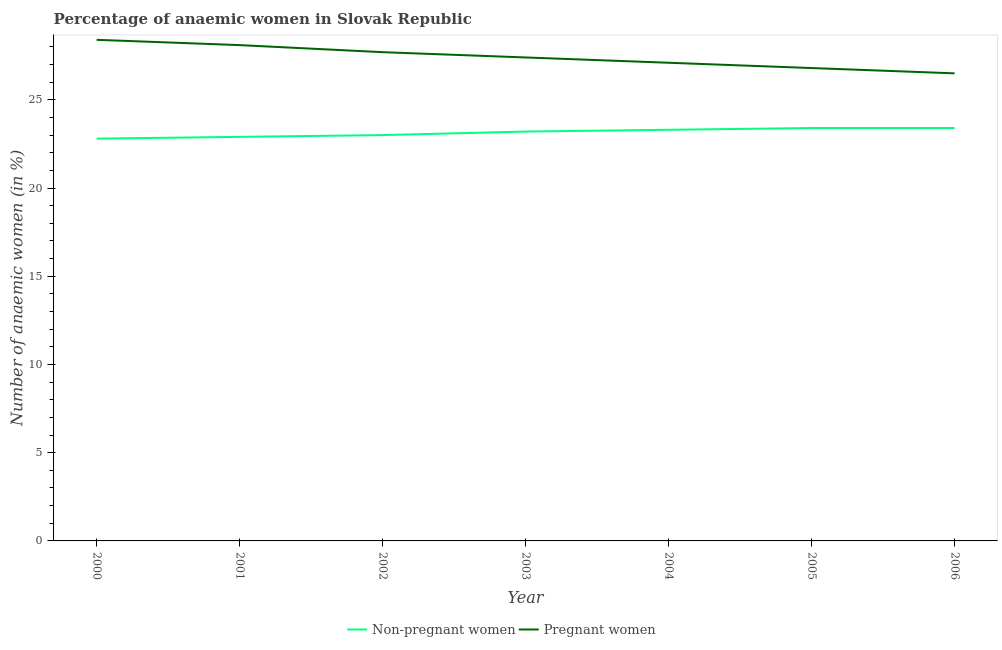What is the percentage of non-pregnant anaemic women in 2004?
Your response must be concise. 23.3. Across all years, what is the maximum percentage of pregnant anaemic women?
Give a very brief answer. 28.4. Across all years, what is the minimum percentage of pregnant anaemic women?
Your answer should be very brief. 26.5. What is the total percentage of non-pregnant anaemic women in the graph?
Provide a short and direct response. 162. What is the difference between the percentage of pregnant anaemic women in 2002 and the percentage of non-pregnant anaemic women in 2001?
Provide a succinct answer. 4.8. What is the average percentage of non-pregnant anaemic women per year?
Make the answer very short. 23.14. In the year 2000, what is the difference between the percentage of pregnant anaemic women and percentage of non-pregnant anaemic women?
Ensure brevity in your answer.  5.6. What is the ratio of the percentage of non-pregnant anaemic women in 2001 to that in 2005?
Make the answer very short. 0.98. Is the percentage of non-pregnant anaemic women in 2003 less than that in 2006?
Offer a very short reply. Yes. Is the difference between the percentage of non-pregnant anaemic women in 2000 and 2005 greater than the difference between the percentage of pregnant anaemic women in 2000 and 2005?
Make the answer very short. No. What is the difference between the highest and the lowest percentage of non-pregnant anaemic women?
Provide a succinct answer. 0.6. In how many years, is the percentage of pregnant anaemic women greater than the average percentage of pregnant anaemic women taken over all years?
Your response must be concise. 3. Does the percentage of non-pregnant anaemic women monotonically increase over the years?
Offer a very short reply. No. Is the percentage of non-pregnant anaemic women strictly less than the percentage of pregnant anaemic women over the years?
Offer a terse response. Yes. How many years are there in the graph?
Provide a short and direct response. 7. What is the difference between two consecutive major ticks on the Y-axis?
Ensure brevity in your answer.  5. Does the graph contain grids?
Give a very brief answer. No. Where does the legend appear in the graph?
Your response must be concise. Bottom center. How many legend labels are there?
Your answer should be compact. 2. How are the legend labels stacked?
Give a very brief answer. Horizontal. What is the title of the graph?
Make the answer very short. Percentage of anaemic women in Slovak Republic. Does "Males" appear as one of the legend labels in the graph?
Provide a succinct answer. No. What is the label or title of the X-axis?
Your answer should be compact. Year. What is the label or title of the Y-axis?
Keep it short and to the point. Number of anaemic women (in %). What is the Number of anaemic women (in %) in Non-pregnant women in 2000?
Make the answer very short. 22.8. What is the Number of anaemic women (in %) of Pregnant women in 2000?
Your response must be concise. 28.4. What is the Number of anaemic women (in %) of Non-pregnant women in 2001?
Keep it short and to the point. 22.9. What is the Number of anaemic women (in %) in Pregnant women in 2001?
Make the answer very short. 28.1. What is the Number of anaemic women (in %) of Pregnant women in 2002?
Your answer should be very brief. 27.7. What is the Number of anaemic women (in %) in Non-pregnant women in 2003?
Provide a short and direct response. 23.2. What is the Number of anaemic women (in %) of Pregnant women in 2003?
Your answer should be compact. 27.4. What is the Number of anaemic women (in %) in Non-pregnant women in 2004?
Your answer should be very brief. 23.3. What is the Number of anaemic women (in %) in Pregnant women in 2004?
Offer a very short reply. 27.1. What is the Number of anaemic women (in %) in Non-pregnant women in 2005?
Keep it short and to the point. 23.4. What is the Number of anaemic women (in %) in Pregnant women in 2005?
Provide a short and direct response. 26.8. What is the Number of anaemic women (in %) of Non-pregnant women in 2006?
Offer a terse response. 23.4. What is the Number of anaemic women (in %) in Pregnant women in 2006?
Offer a very short reply. 26.5. Across all years, what is the maximum Number of anaemic women (in %) of Non-pregnant women?
Keep it short and to the point. 23.4. Across all years, what is the maximum Number of anaemic women (in %) in Pregnant women?
Give a very brief answer. 28.4. Across all years, what is the minimum Number of anaemic women (in %) in Non-pregnant women?
Your response must be concise. 22.8. Across all years, what is the minimum Number of anaemic women (in %) of Pregnant women?
Offer a very short reply. 26.5. What is the total Number of anaemic women (in %) in Non-pregnant women in the graph?
Offer a very short reply. 162. What is the total Number of anaemic women (in %) in Pregnant women in the graph?
Provide a succinct answer. 192. What is the difference between the Number of anaemic women (in %) in Pregnant women in 2000 and that in 2001?
Keep it short and to the point. 0.3. What is the difference between the Number of anaemic women (in %) of Non-pregnant women in 2000 and that in 2002?
Keep it short and to the point. -0.2. What is the difference between the Number of anaemic women (in %) of Pregnant women in 2000 and that in 2002?
Ensure brevity in your answer.  0.7. What is the difference between the Number of anaemic women (in %) of Non-pregnant women in 2000 and that in 2003?
Keep it short and to the point. -0.4. What is the difference between the Number of anaemic women (in %) of Non-pregnant women in 2000 and that in 2004?
Keep it short and to the point. -0.5. What is the difference between the Number of anaemic women (in %) in Non-pregnant women in 2000 and that in 2005?
Ensure brevity in your answer.  -0.6. What is the difference between the Number of anaemic women (in %) in Non-pregnant women in 2000 and that in 2006?
Ensure brevity in your answer.  -0.6. What is the difference between the Number of anaemic women (in %) of Pregnant women in 2000 and that in 2006?
Your answer should be compact. 1.9. What is the difference between the Number of anaemic women (in %) of Non-pregnant women in 2001 and that in 2005?
Your response must be concise. -0.5. What is the difference between the Number of anaemic women (in %) of Pregnant women in 2001 and that in 2005?
Your response must be concise. 1.3. What is the difference between the Number of anaemic women (in %) of Non-pregnant women in 2001 and that in 2006?
Provide a short and direct response. -0.5. What is the difference between the Number of anaemic women (in %) in Non-pregnant women in 2002 and that in 2003?
Keep it short and to the point. -0.2. What is the difference between the Number of anaemic women (in %) of Non-pregnant women in 2002 and that in 2006?
Provide a short and direct response. -0.4. What is the difference between the Number of anaemic women (in %) in Pregnant women in 2002 and that in 2006?
Keep it short and to the point. 1.2. What is the difference between the Number of anaemic women (in %) in Pregnant women in 2003 and that in 2004?
Make the answer very short. 0.3. What is the difference between the Number of anaemic women (in %) of Non-pregnant women in 2003 and that in 2005?
Keep it short and to the point. -0.2. What is the difference between the Number of anaemic women (in %) in Non-pregnant women in 2003 and that in 2006?
Your answer should be compact. -0.2. What is the difference between the Number of anaemic women (in %) in Pregnant women in 2005 and that in 2006?
Your answer should be compact. 0.3. What is the difference between the Number of anaemic women (in %) in Non-pregnant women in 2000 and the Number of anaemic women (in %) in Pregnant women in 2001?
Provide a succinct answer. -5.3. What is the difference between the Number of anaemic women (in %) of Non-pregnant women in 2000 and the Number of anaemic women (in %) of Pregnant women in 2002?
Offer a terse response. -4.9. What is the difference between the Number of anaemic women (in %) of Non-pregnant women in 2000 and the Number of anaemic women (in %) of Pregnant women in 2004?
Your response must be concise. -4.3. What is the difference between the Number of anaemic women (in %) in Non-pregnant women in 2000 and the Number of anaemic women (in %) in Pregnant women in 2006?
Give a very brief answer. -3.7. What is the difference between the Number of anaemic women (in %) of Non-pregnant women in 2001 and the Number of anaemic women (in %) of Pregnant women in 2002?
Your answer should be very brief. -4.8. What is the difference between the Number of anaemic women (in %) of Non-pregnant women in 2001 and the Number of anaemic women (in %) of Pregnant women in 2003?
Provide a short and direct response. -4.5. What is the difference between the Number of anaemic women (in %) in Non-pregnant women in 2002 and the Number of anaemic women (in %) in Pregnant women in 2004?
Ensure brevity in your answer.  -4.1. What is the difference between the Number of anaemic women (in %) in Non-pregnant women in 2002 and the Number of anaemic women (in %) in Pregnant women in 2006?
Your response must be concise. -3.5. What is the difference between the Number of anaemic women (in %) in Non-pregnant women in 2003 and the Number of anaemic women (in %) in Pregnant women in 2004?
Your answer should be very brief. -3.9. What is the difference between the Number of anaemic women (in %) of Non-pregnant women in 2004 and the Number of anaemic women (in %) of Pregnant women in 2005?
Ensure brevity in your answer.  -3.5. What is the difference between the Number of anaemic women (in %) in Non-pregnant women in 2004 and the Number of anaemic women (in %) in Pregnant women in 2006?
Your answer should be compact. -3.2. What is the difference between the Number of anaemic women (in %) of Non-pregnant women in 2005 and the Number of anaemic women (in %) of Pregnant women in 2006?
Keep it short and to the point. -3.1. What is the average Number of anaemic women (in %) of Non-pregnant women per year?
Your response must be concise. 23.14. What is the average Number of anaemic women (in %) in Pregnant women per year?
Provide a short and direct response. 27.43. In the year 2001, what is the difference between the Number of anaemic women (in %) of Non-pregnant women and Number of anaemic women (in %) of Pregnant women?
Offer a very short reply. -5.2. In the year 2003, what is the difference between the Number of anaemic women (in %) in Non-pregnant women and Number of anaemic women (in %) in Pregnant women?
Give a very brief answer. -4.2. In the year 2006, what is the difference between the Number of anaemic women (in %) of Non-pregnant women and Number of anaemic women (in %) of Pregnant women?
Offer a very short reply. -3.1. What is the ratio of the Number of anaemic women (in %) in Pregnant women in 2000 to that in 2001?
Provide a succinct answer. 1.01. What is the ratio of the Number of anaemic women (in %) in Non-pregnant women in 2000 to that in 2002?
Your response must be concise. 0.99. What is the ratio of the Number of anaemic women (in %) of Pregnant women in 2000 to that in 2002?
Make the answer very short. 1.03. What is the ratio of the Number of anaemic women (in %) in Non-pregnant women in 2000 to that in 2003?
Your answer should be compact. 0.98. What is the ratio of the Number of anaemic women (in %) of Pregnant women in 2000 to that in 2003?
Give a very brief answer. 1.04. What is the ratio of the Number of anaemic women (in %) of Non-pregnant women in 2000 to that in 2004?
Provide a succinct answer. 0.98. What is the ratio of the Number of anaemic women (in %) of Pregnant women in 2000 to that in 2004?
Provide a succinct answer. 1.05. What is the ratio of the Number of anaemic women (in %) in Non-pregnant women in 2000 to that in 2005?
Keep it short and to the point. 0.97. What is the ratio of the Number of anaemic women (in %) of Pregnant women in 2000 to that in 2005?
Offer a terse response. 1.06. What is the ratio of the Number of anaemic women (in %) of Non-pregnant women in 2000 to that in 2006?
Your answer should be very brief. 0.97. What is the ratio of the Number of anaemic women (in %) of Pregnant women in 2000 to that in 2006?
Give a very brief answer. 1.07. What is the ratio of the Number of anaemic women (in %) in Non-pregnant women in 2001 to that in 2002?
Your answer should be very brief. 1. What is the ratio of the Number of anaemic women (in %) of Pregnant women in 2001 to that in 2002?
Ensure brevity in your answer.  1.01. What is the ratio of the Number of anaemic women (in %) in Non-pregnant women in 2001 to that in 2003?
Make the answer very short. 0.99. What is the ratio of the Number of anaemic women (in %) of Pregnant women in 2001 to that in 2003?
Ensure brevity in your answer.  1.03. What is the ratio of the Number of anaemic women (in %) of Non-pregnant women in 2001 to that in 2004?
Keep it short and to the point. 0.98. What is the ratio of the Number of anaemic women (in %) in Pregnant women in 2001 to that in 2004?
Offer a terse response. 1.04. What is the ratio of the Number of anaemic women (in %) of Non-pregnant women in 2001 to that in 2005?
Keep it short and to the point. 0.98. What is the ratio of the Number of anaemic women (in %) in Pregnant women in 2001 to that in 2005?
Offer a very short reply. 1.05. What is the ratio of the Number of anaemic women (in %) in Non-pregnant women in 2001 to that in 2006?
Your answer should be compact. 0.98. What is the ratio of the Number of anaemic women (in %) of Pregnant women in 2001 to that in 2006?
Ensure brevity in your answer.  1.06. What is the ratio of the Number of anaemic women (in %) of Non-pregnant women in 2002 to that in 2003?
Make the answer very short. 0.99. What is the ratio of the Number of anaemic women (in %) of Pregnant women in 2002 to that in 2003?
Offer a very short reply. 1.01. What is the ratio of the Number of anaemic women (in %) of Non-pregnant women in 2002 to that in 2004?
Your response must be concise. 0.99. What is the ratio of the Number of anaemic women (in %) of Pregnant women in 2002 to that in 2004?
Provide a short and direct response. 1.02. What is the ratio of the Number of anaemic women (in %) in Non-pregnant women in 2002 to that in 2005?
Your answer should be very brief. 0.98. What is the ratio of the Number of anaemic women (in %) of Pregnant women in 2002 to that in 2005?
Keep it short and to the point. 1.03. What is the ratio of the Number of anaemic women (in %) of Non-pregnant women in 2002 to that in 2006?
Offer a terse response. 0.98. What is the ratio of the Number of anaemic women (in %) of Pregnant women in 2002 to that in 2006?
Offer a very short reply. 1.05. What is the ratio of the Number of anaemic women (in %) of Non-pregnant women in 2003 to that in 2004?
Your answer should be compact. 1. What is the ratio of the Number of anaemic women (in %) of Pregnant women in 2003 to that in 2004?
Provide a succinct answer. 1.01. What is the ratio of the Number of anaemic women (in %) in Non-pregnant women in 2003 to that in 2005?
Ensure brevity in your answer.  0.99. What is the ratio of the Number of anaemic women (in %) of Pregnant women in 2003 to that in 2005?
Provide a succinct answer. 1.02. What is the ratio of the Number of anaemic women (in %) of Pregnant women in 2003 to that in 2006?
Offer a very short reply. 1.03. What is the ratio of the Number of anaemic women (in %) in Pregnant women in 2004 to that in 2005?
Your response must be concise. 1.01. What is the ratio of the Number of anaemic women (in %) in Pregnant women in 2004 to that in 2006?
Your answer should be compact. 1.02. What is the ratio of the Number of anaemic women (in %) of Pregnant women in 2005 to that in 2006?
Offer a very short reply. 1.01. What is the difference between the highest and the lowest Number of anaemic women (in %) of Pregnant women?
Your response must be concise. 1.9. 